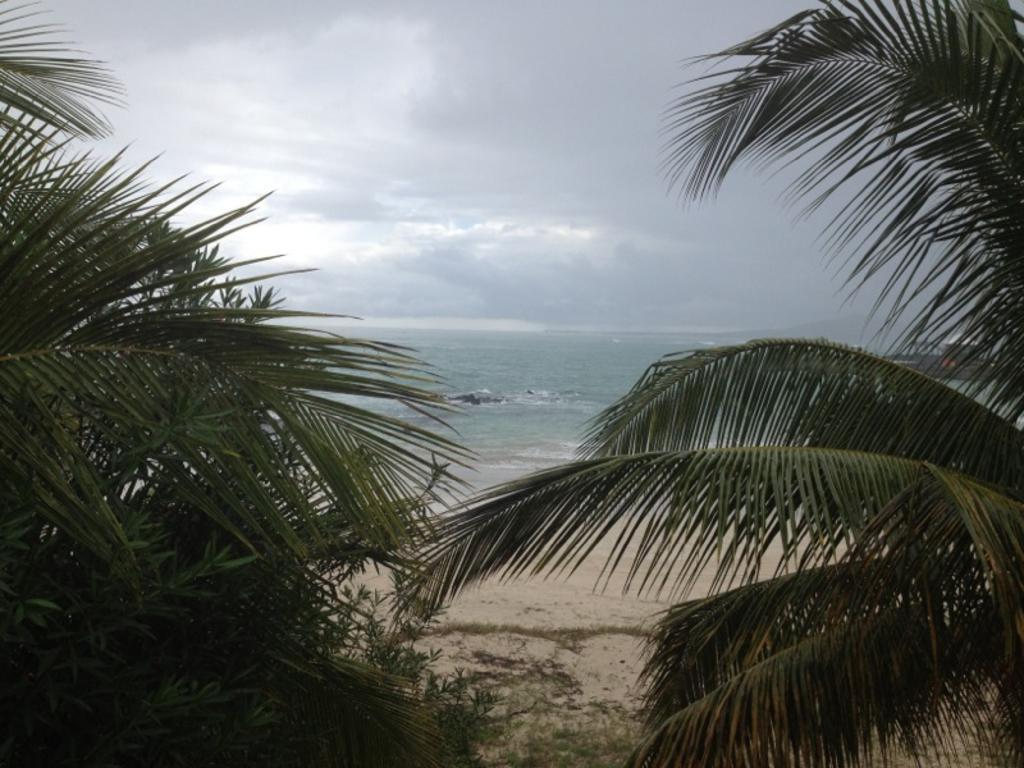How would you summarize this image in a sentence or two? In this image we can see one sea, some trees, some grass on the surface near to the sea, one object in the water and at the top there is the cloudy sky. 